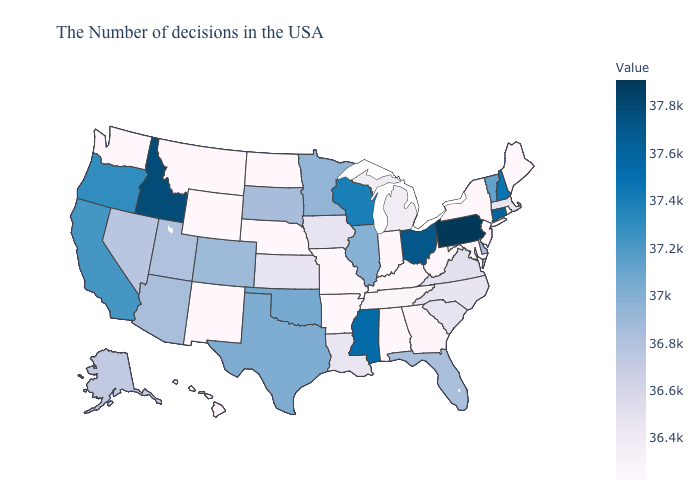Does Colorado have a lower value than Washington?
Concise answer only. No. Does the map have missing data?
Quick response, please. No. Among the states that border New Hampshire , does Maine have the highest value?
Be succinct. No. Does Alaska have a higher value than Massachusetts?
Be succinct. Yes. Does Vermont have the highest value in the Northeast?
Concise answer only. No. Which states have the highest value in the USA?
Be succinct. Pennsylvania. Which states have the lowest value in the USA?
Be succinct. Maine, Rhode Island, New York, New Jersey, Maryland, West Virginia, Kentucky, Indiana, Alabama, Missouri, Arkansas, Nebraska, North Dakota, Wyoming, New Mexico, Washington, Hawaii. 